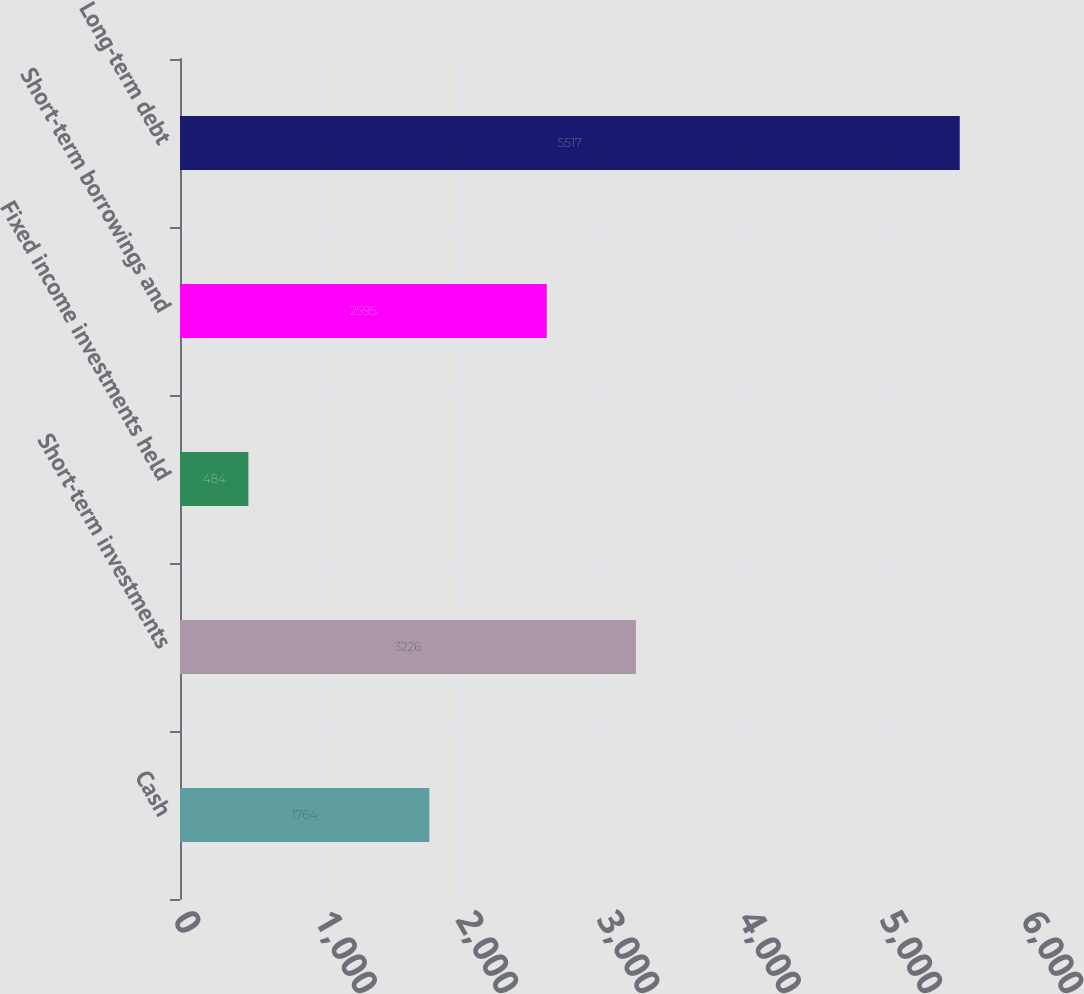Convert chart. <chart><loc_0><loc_0><loc_500><loc_500><bar_chart><fcel>Cash<fcel>Short-term investments<fcel>Fixed income investments held<fcel>Short-term borrowings and<fcel>Long-term debt<nl><fcel>1764<fcel>3226<fcel>484<fcel>2595<fcel>5517<nl></chart> 